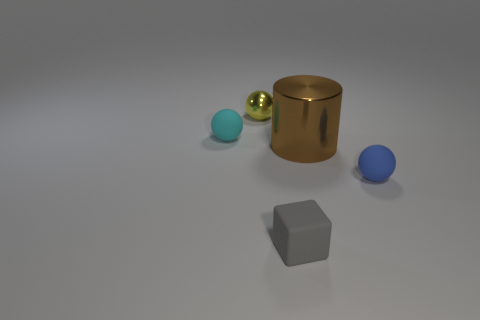Add 2 gray blocks. How many objects exist? 7 Subtract all blocks. How many objects are left? 4 Add 5 small gray rubber objects. How many small gray rubber objects exist? 6 Subtract 0 green cylinders. How many objects are left? 5 Subtract all small yellow balls. Subtract all tiny brown metallic cylinders. How many objects are left? 4 Add 4 cyan matte objects. How many cyan matte objects are left? 5 